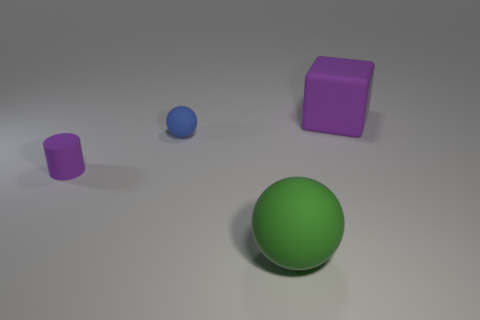What number of things are either large purple things right of the tiny sphere or purple matte cylinders?
Your answer should be compact. 2. Does the rubber cylinder have the same color as the matte block?
Offer a terse response. Yes. Are there any purple rubber things of the same size as the blue thing?
Your response must be concise. Yes. What number of purple rubber things are right of the tiny ball and to the left of the purple cube?
Give a very brief answer. 0. How many small blue rubber balls are in front of the purple cylinder?
Offer a very short reply. 0. Are there any other green things of the same shape as the green object?
Offer a very short reply. No. Is the shape of the blue object the same as the matte object that is to the left of the blue rubber thing?
Your response must be concise. No. How many balls are either matte things or blue rubber things?
Give a very brief answer. 2. What shape is the object that is to the right of the green object?
Keep it short and to the point. Cube. What number of big purple cubes have the same material as the small cylinder?
Ensure brevity in your answer.  1. 